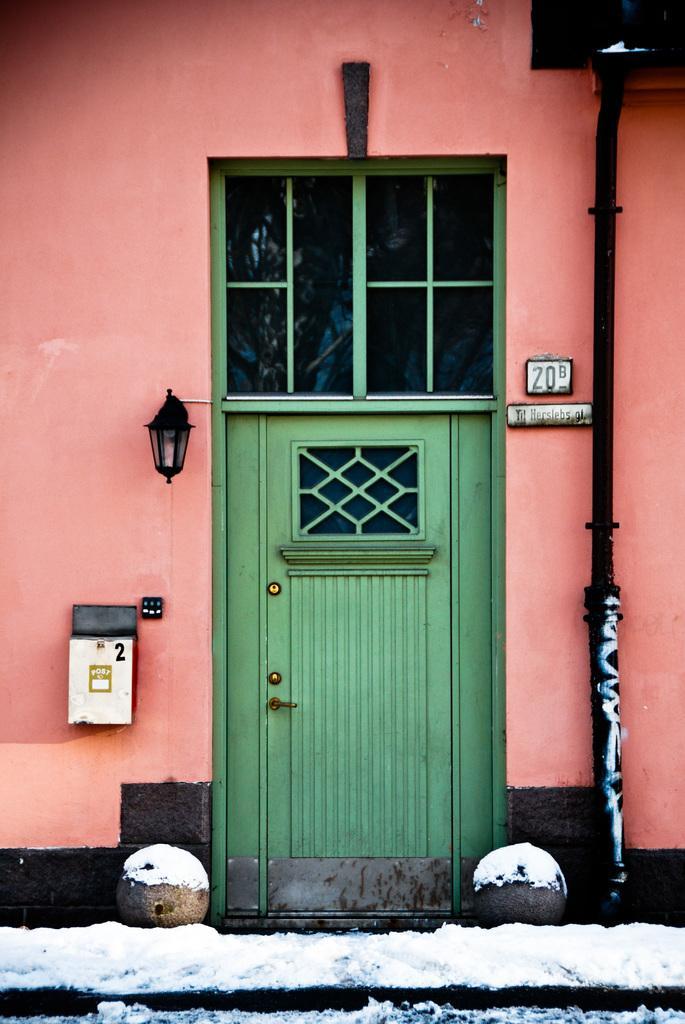In one or two sentences, can you explain what this image depicts? In this picture we can observe a green color door. We can observe a pink color wall. There is some snow in front of this wall. We can observe a black color pipe. 